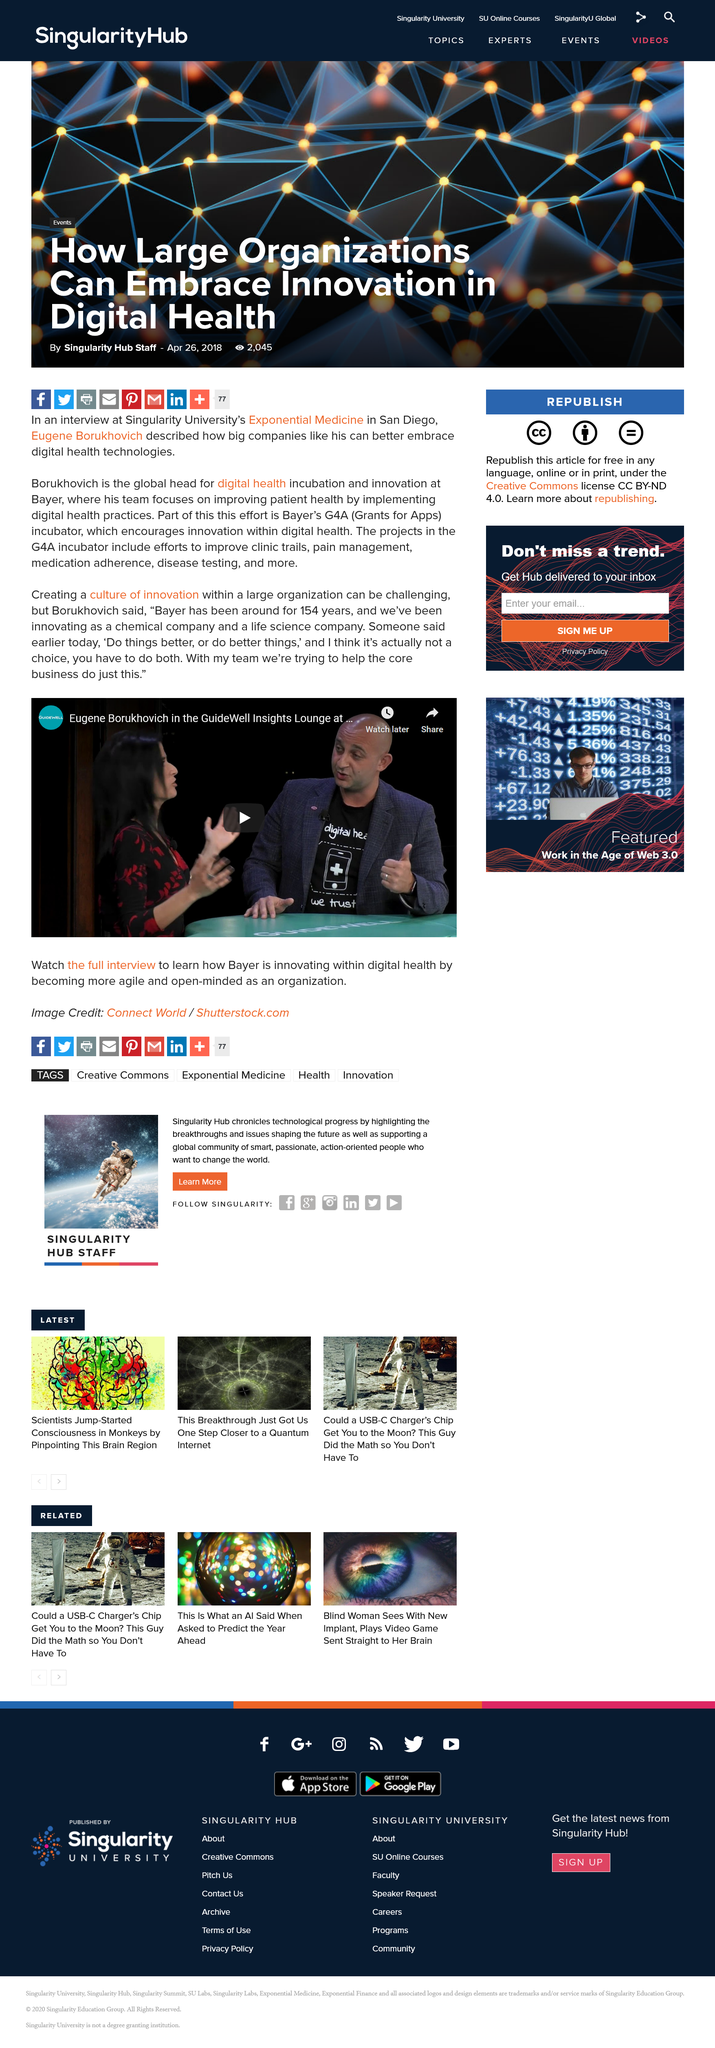Indicate a few pertinent items in this graphic. Borukhovich's team is dedicated to improving patient health by implementing digital health practices, with a focus on providing high-quality and efficient care. The conversation with Bayer's head of digital health incubation and innovation is taking place in the photo of the video, which is located in the GuideWell Insights Lounge. Bayer's G4A incubator encourages innovation within the field of digital health by providing resources and support to startups working on cutting-edge technology and novel ideas. 